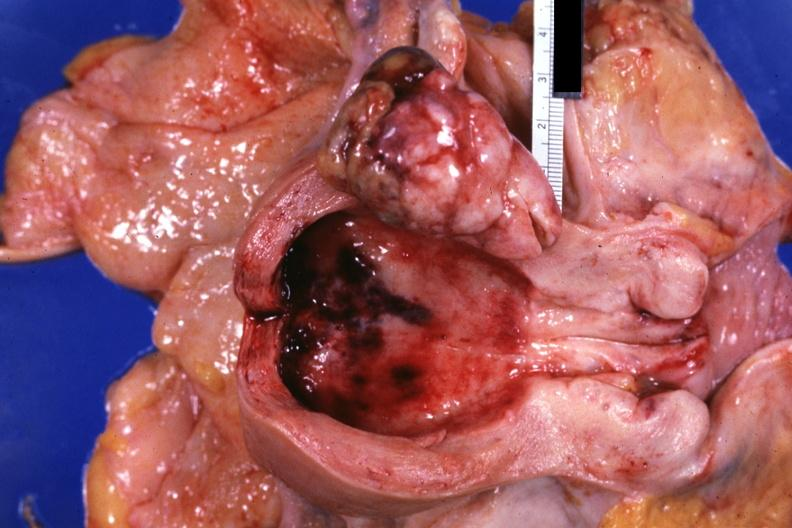s conjoined twins present?
Answer the question using a single word or phrase. No 